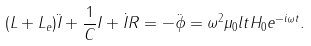<formula> <loc_0><loc_0><loc_500><loc_500>( L + L _ { e } ) \ddot { I } + \frac { 1 } { C } I + \dot { I } R = - \ddot { \phi } = \omega ^ { 2 } \mu _ { 0 } l t H _ { 0 } e ^ { - i \omega t } .</formula> 